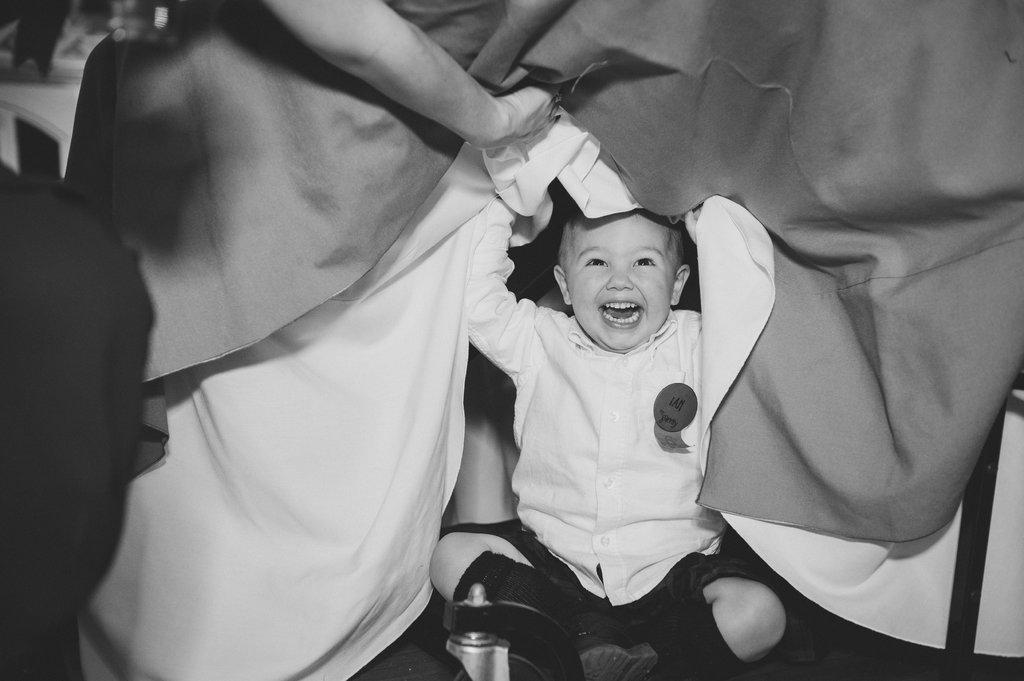Could you give a brief overview of what you see in this image? In the given picture, We can see a child sitting and laughing holding a blankets after that i can see a water bottle next a person's hand is available and holding a blanket. 